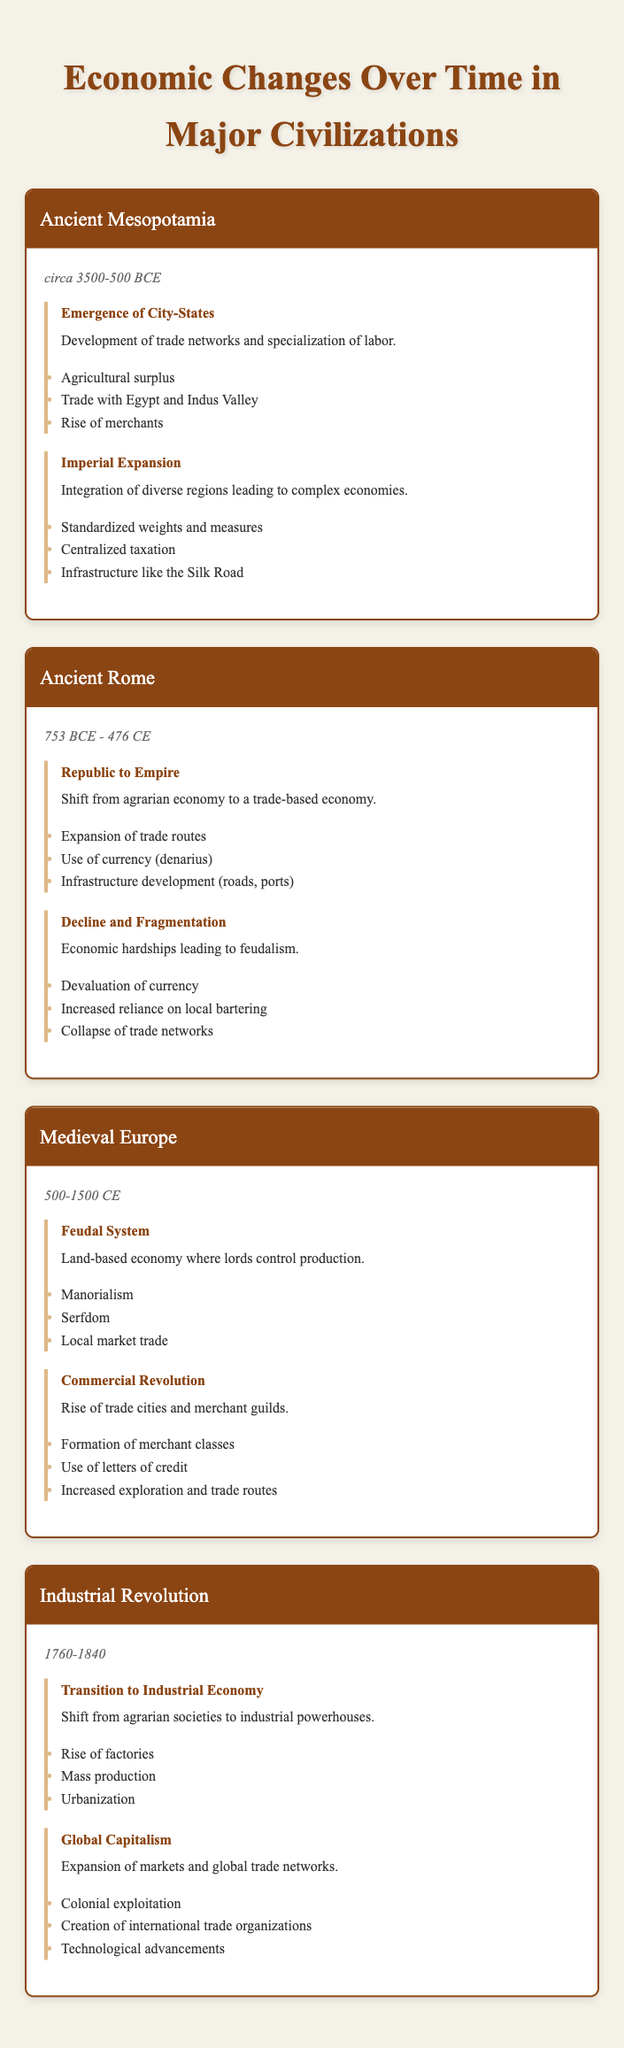What time period does Ancient Mesopotamia cover? The time period for Ancient Mesopotamia is listed as "circa 3500-500 BCE" in the table.
Answer: circa 3500-500 BCE What were the key features of the "Transition to Industrial Economy" phase? The key features listed for this phase are "Rise of factories," "Mass production," and "Urbanization."
Answer: Rise of factories, Mass production, Urbanization True or False: The Medieval Europe economy during the "Commercial Revolution" was based on serfdom. The "Feudal System" phase mentions serfdom as a key feature, but the "Commercial Revolution" phase focuses on trade cities and merchant guilds, which indicates a shift away from serfdom for economic activity. Therefore, the statement is false.
Answer: False How did the economic features of Ancient Rome's "Decline and Fragmentation" phase compare to the "Republic to Empire" phase? In the "Republic to Empire" phase, key features included "Expansion of trade routes," "Use of currency (denarius)," and "Infrastructure development." In contrast, the "Decline and Fragmentation" phase highlights "Devaluation of currency," "Increased reliance on local bartering," and "Collapse of trade networks." This indicates a regression in the economy as trade networks collapsed and reliance on bartering increased. Therefore, the comparison shows a decline in economic sophistication.
Answer: Economic regression What is the total number of economic phases described for the Industrial Revolution? There are two phases listed for the Industrial Revolution: "Transition to Industrial Economy" and "Global Capitalism." Therefore, adding these gives a total of two phases.
Answer: 2 Which civilization experienced an integration of diverse regions leading to complex economies? The phase called "Imperial Expansion" under Ancient Mesopotamia describes the integration of diverse regions leading to complex economies.
Answer: Ancient Mesopotamia What geographical trade was Ancient Mesopotamia involved in? The economic changes under the "Emergence of City-States" phase state that there was "Trade with Egypt and Indus Valley," indicating the geographical trade regions involved.
Answer: Egypt and Indus Valley How many key features are listed under "Commercial Revolution" for Medieval Europe? The "Commercial Revolution" phase lists three key features: "Formation of merchant classes," "Use of letters of credit," and "Increased exploration and trade routes." Therefore, the total number of key features is three.
Answer: 3 What transition occurred in Ancient Rome's economy during the shift from Republic to Empire? The answer is found in the description of the "Republic to Empire" phase, which states there was a shift "from agrarian economy to a trade-based economy," indicating a significant change from primarily farming to trade focus.
Answer: Shift to trade-based economy 